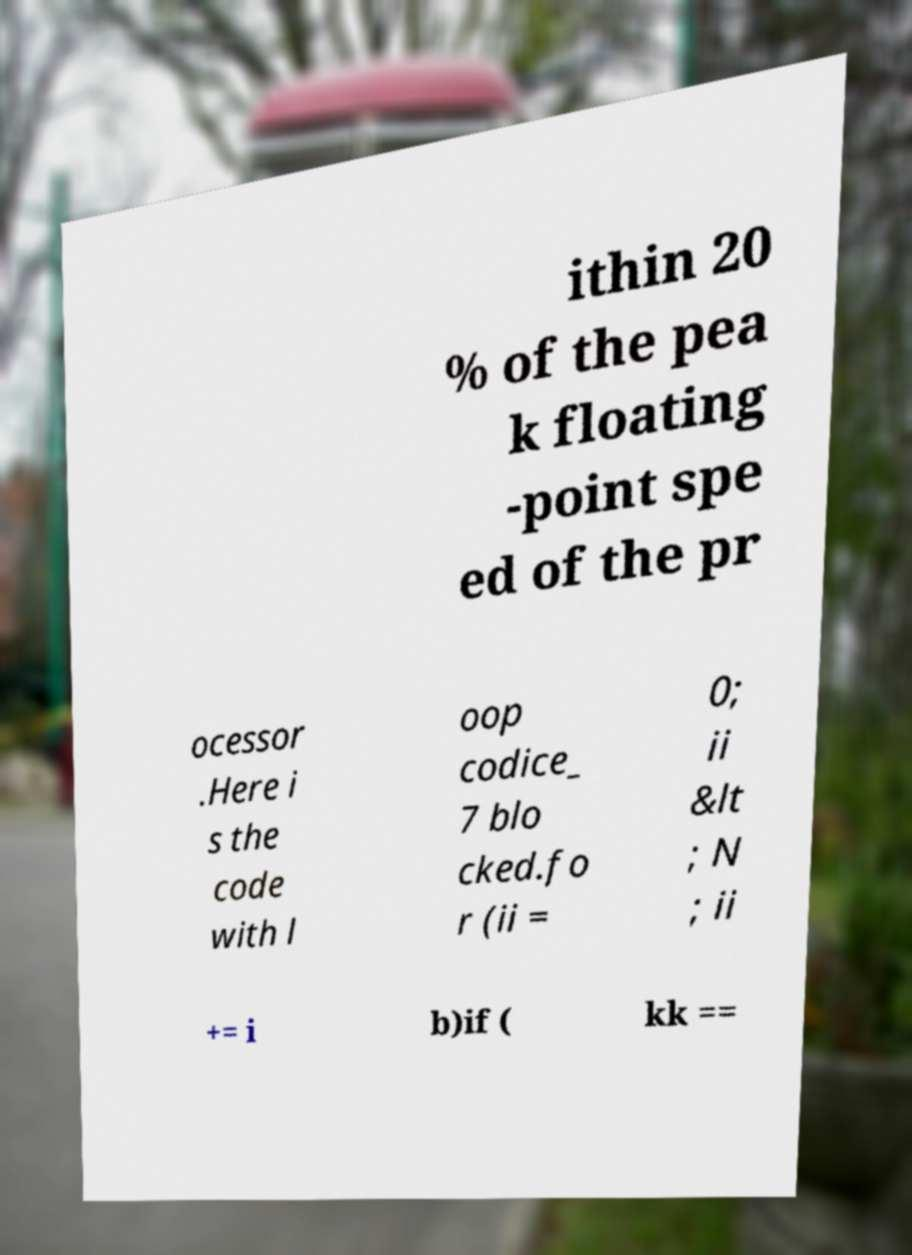Please read and relay the text visible in this image. What does it say? ithin 20 % of the pea k floating -point spe ed of the pr ocessor .Here i s the code with l oop codice_ 7 blo cked.fo r (ii = 0; ii &lt ; N ; ii += i b)if ( kk == 